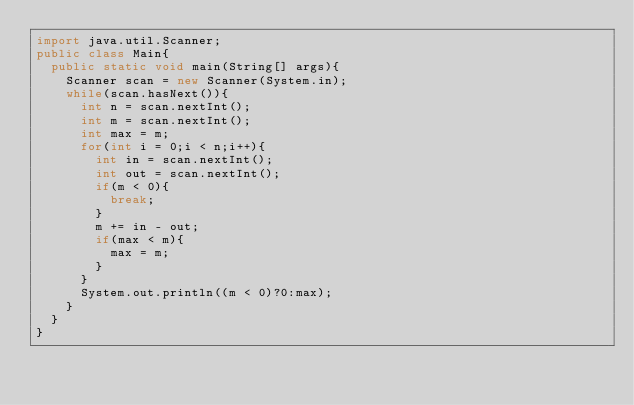Convert code to text. <code><loc_0><loc_0><loc_500><loc_500><_Java_>import java.util.Scanner;
public class Main{
	public static void main(String[] args){
		Scanner scan = new Scanner(System.in);
		while(scan.hasNext()){
			int n = scan.nextInt();
			int m = scan.nextInt();
			int max = m;
			for(int i = 0;i < n;i++){
				int in = scan.nextInt();
				int out = scan.nextInt();
				if(m < 0){
					break;
				}
				m += in - out;
				if(max < m){
					max = m;
				}
			}
			System.out.println((m < 0)?0:max);
		}
	}
}</code> 